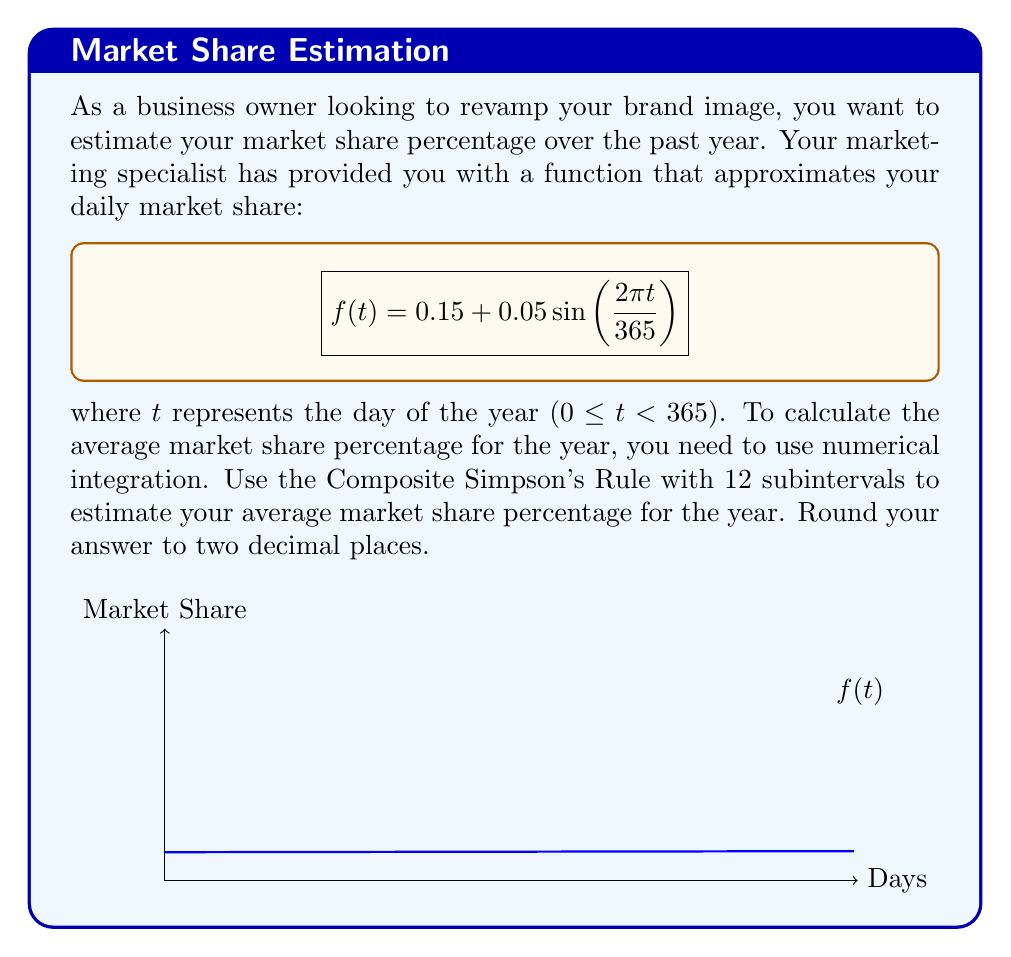Show me your answer to this math problem. To solve this problem, we'll use the Composite Simpson's Rule with 12 subintervals:

1) The formula for Composite Simpson's Rule is:

   $$\int_a^b f(x)dx \approx \frac{h}{3}\left[f(x_0) + 4f(x_1) + 2f(x_2) + 4f(x_3) + ... + 2f(x_{n-2}) + 4f(x_{n-1}) + f(x_n)\right]$$

   where $h = \frac{b-a}{n}$, $n$ is the number of subintervals (12 in this case), and $x_i = a + ih$.

2) In our case, $a = 0$, $b = 365$, and $n = 12$. So, $h = \frac{365}{12} \approx 30.4167$.

3) Calculate the $x_i$ values:
   $x_0 = 0$, $x_1 = 30.4167$, $x_2 = 60.8333$, ..., $x_{12} = 365$

4) Evaluate $f(x_i)$ for each $x_i$:
   $f(x_0) = 0.15$
   $f(x_1) = 0.15 + 0.05\sin(\frac{2\pi \cdot 30.4167}{365}) \approx 0.1916$
   $f(x_2) = 0.15 + 0.05\sin(\frac{2\pi \cdot 60.8333}{365}) \approx 0.1992$
   ...
   $f(x_{12}) = 0.15$

5) Apply the Composite Simpson's Rule:

   $$\frac{30.4167}{3}[0.15 + 4(0.1916) + 2(0.1992) + ... + 4(0.1916) + 0.15] \approx 54.7506$$

6) To get the average market share, divide by the number of days:

   Average Market Share = $\frac{54.7506}{365} \approx 0.1500$ or 15.00%
Answer: 15.00% 